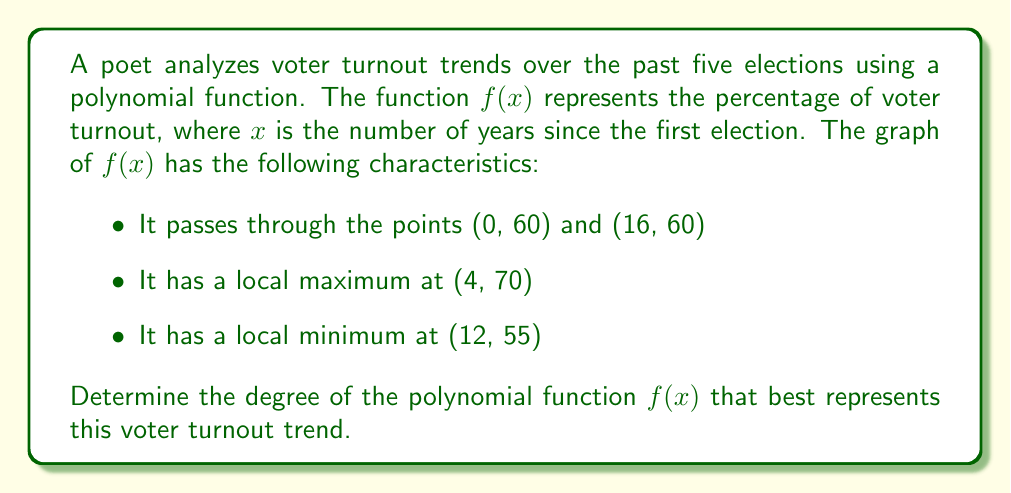Can you answer this question? Let's analyze this step-by-step:

1) First, we need to understand what each characteristic tells us about the function:
   - Passing through (0, 60) and (16, 60) means the function starts and ends at the same y-value.
   - Having a local maximum at (4, 70) means the function increases and then decreases around x = 4.
   - Having a local minimum at (12, 55) means the function decreases and then increases around x = 12.

2) The number of turning points (local maxima and minima) in a polynomial function is at most one less than its degree.

3) In this case, we have two turning points: a local maximum and a local minimum.

4) The minimum degree of a polynomial that can have two turning points is 3.

5) A cubic function (degree 3) can have at most two turning points, which matches our scenario.

6) Higher degree polynomials could also fit this description, but we're looking for the simplest (lowest degree) polynomial that satisfies all conditions.

7) Therefore, the degree of the polynomial function that best represents this voter turnout trend is 3.
Answer: 3 